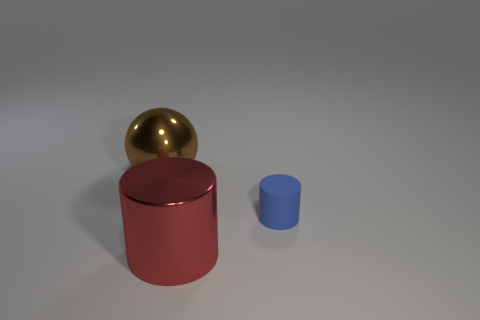There is a shiny thing that is in front of the blue matte object; is it the same size as the thing that is behind the blue matte cylinder?
Your answer should be compact. Yes. There is a metallic object behind the small blue rubber thing; what shape is it?
Ensure brevity in your answer.  Sphere. There is a tiny blue object that is the same shape as the red metallic thing; what material is it?
Make the answer very short. Rubber. There is a metal thing behind the blue object; is it the same size as the big red object?
Offer a terse response. Yes. There is a large ball; how many big metallic things are to the right of it?
Ensure brevity in your answer.  1. Are there fewer blue matte cylinders in front of the blue rubber thing than metallic cylinders behind the big red metal object?
Provide a succinct answer. No. What number of blue matte objects are there?
Provide a short and direct response. 1. What color is the metallic thing that is to the left of the big shiny cylinder?
Make the answer very short. Brown. How big is the shiny sphere?
Provide a short and direct response. Large. There is a large shiny ball; is its color the same as the large thing that is right of the brown metallic sphere?
Offer a terse response. No. 